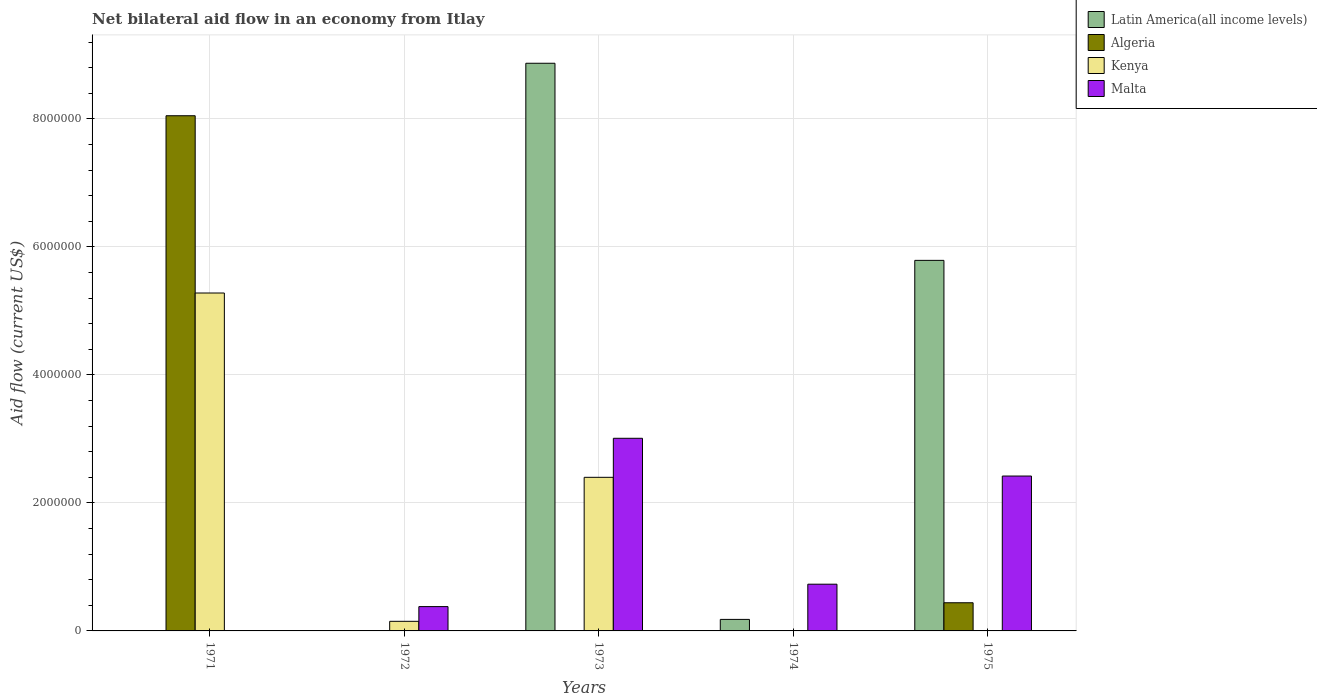Are the number of bars on each tick of the X-axis equal?
Offer a terse response. No. What is the label of the 4th group of bars from the left?
Make the answer very short. 1974. What is the net bilateral aid flow in Kenya in 1973?
Offer a very short reply. 2.40e+06. Across all years, what is the maximum net bilateral aid flow in Kenya?
Give a very brief answer. 5.28e+06. Across all years, what is the minimum net bilateral aid flow in Algeria?
Offer a terse response. 0. What is the total net bilateral aid flow in Malta in the graph?
Your response must be concise. 6.54e+06. What is the difference between the net bilateral aid flow in Kenya in 1971 and that in 1973?
Provide a short and direct response. 2.88e+06. What is the average net bilateral aid flow in Latin America(all income levels) per year?
Provide a short and direct response. 2.97e+06. In the year 1975, what is the difference between the net bilateral aid flow in Algeria and net bilateral aid flow in Malta?
Offer a terse response. -1.98e+06. What is the ratio of the net bilateral aid flow in Malta in 1973 to that in 1975?
Offer a terse response. 1.24. What is the difference between the highest and the second highest net bilateral aid flow in Latin America(all income levels)?
Your answer should be compact. 3.08e+06. What is the difference between the highest and the lowest net bilateral aid flow in Malta?
Your answer should be very brief. 3.01e+06. Is the sum of the net bilateral aid flow in Kenya in 1972 and 1973 greater than the maximum net bilateral aid flow in Malta across all years?
Keep it short and to the point. No. Is it the case that in every year, the sum of the net bilateral aid flow in Kenya and net bilateral aid flow in Malta is greater than the sum of net bilateral aid flow in Latin America(all income levels) and net bilateral aid flow in Algeria?
Offer a terse response. Yes. Are all the bars in the graph horizontal?
Your response must be concise. No. What is the difference between two consecutive major ticks on the Y-axis?
Offer a terse response. 2.00e+06. Does the graph contain grids?
Make the answer very short. Yes. Where does the legend appear in the graph?
Your response must be concise. Top right. How many legend labels are there?
Your response must be concise. 4. What is the title of the graph?
Provide a succinct answer. Net bilateral aid flow in an economy from Itlay. What is the label or title of the X-axis?
Your answer should be very brief. Years. What is the label or title of the Y-axis?
Provide a short and direct response. Aid flow (current US$). What is the Aid flow (current US$) of Latin America(all income levels) in 1971?
Provide a short and direct response. 0. What is the Aid flow (current US$) of Algeria in 1971?
Offer a very short reply. 8.05e+06. What is the Aid flow (current US$) of Kenya in 1971?
Offer a terse response. 5.28e+06. What is the Aid flow (current US$) of Malta in 1971?
Make the answer very short. 0. What is the Aid flow (current US$) of Latin America(all income levels) in 1972?
Provide a succinct answer. 0. What is the Aid flow (current US$) in Latin America(all income levels) in 1973?
Provide a short and direct response. 8.87e+06. What is the Aid flow (current US$) in Algeria in 1973?
Provide a short and direct response. 0. What is the Aid flow (current US$) of Kenya in 1973?
Offer a terse response. 2.40e+06. What is the Aid flow (current US$) of Malta in 1973?
Provide a short and direct response. 3.01e+06. What is the Aid flow (current US$) of Algeria in 1974?
Ensure brevity in your answer.  0. What is the Aid flow (current US$) of Malta in 1974?
Keep it short and to the point. 7.30e+05. What is the Aid flow (current US$) in Latin America(all income levels) in 1975?
Your answer should be very brief. 5.79e+06. What is the Aid flow (current US$) of Kenya in 1975?
Your response must be concise. 0. What is the Aid flow (current US$) in Malta in 1975?
Keep it short and to the point. 2.42e+06. Across all years, what is the maximum Aid flow (current US$) of Latin America(all income levels)?
Provide a short and direct response. 8.87e+06. Across all years, what is the maximum Aid flow (current US$) in Algeria?
Offer a terse response. 8.05e+06. Across all years, what is the maximum Aid flow (current US$) of Kenya?
Offer a terse response. 5.28e+06. Across all years, what is the maximum Aid flow (current US$) of Malta?
Give a very brief answer. 3.01e+06. Across all years, what is the minimum Aid flow (current US$) of Latin America(all income levels)?
Offer a terse response. 0. Across all years, what is the minimum Aid flow (current US$) of Malta?
Your answer should be very brief. 0. What is the total Aid flow (current US$) of Latin America(all income levels) in the graph?
Offer a very short reply. 1.48e+07. What is the total Aid flow (current US$) of Algeria in the graph?
Your answer should be compact. 8.49e+06. What is the total Aid flow (current US$) in Kenya in the graph?
Your answer should be compact. 7.83e+06. What is the total Aid flow (current US$) in Malta in the graph?
Provide a succinct answer. 6.54e+06. What is the difference between the Aid flow (current US$) of Kenya in 1971 and that in 1972?
Your answer should be very brief. 5.13e+06. What is the difference between the Aid flow (current US$) in Kenya in 1971 and that in 1973?
Give a very brief answer. 2.88e+06. What is the difference between the Aid flow (current US$) of Algeria in 1971 and that in 1975?
Offer a terse response. 7.61e+06. What is the difference between the Aid flow (current US$) of Kenya in 1972 and that in 1973?
Your answer should be compact. -2.25e+06. What is the difference between the Aid flow (current US$) of Malta in 1972 and that in 1973?
Your answer should be compact. -2.63e+06. What is the difference between the Aid flow (current US$) in Malta in 1972 and that in 1974?
Your answer should be very brief. -3.50e+05. What is the difference between the Aid flow (current US$) of Malta in 1972 and that in 1975?
Offer a very short reply. -2.04e+06. What is the difference between the Aid flow (current US$) in Latin America(all income levels) in 1973 and that in 1974?
Your response must be concise. 8.69e+06. What is the difference between the Aid flow (current US$) in Malta in 1973 and that in 1974?
Keep it short and to the point. 2.28e+06. What is the difference between the Aid flow (current US$) in Latin America(all income levels) in 1973 and that in 1975?
Provide a succinct answer. 3.08e+06. What is the difference between the Aid flow (current US$) of Malta in 1973 and that in 1975?
Your answer should be very brief. 5.90e+05. What is the difference between the Aid flow (current US$) of Latin America(all income levels) in 1974 and that in 1975?
Your response must be concise. -5.61e+06. What is the difference between the Aid flow (current US$) of Malta in 1974 and that in 1975?
Give a very brief answer. -1.69e+06. What is the difference between the Aid flow (current US$) of Algeria in 1971 and the Aid flow (current US$) of Kenya in 1972?
Offer a terse response. 7.90e+06. What is the difference between the Aid flow (current US$) of Algeria in 1971 and the Aid flow (current US$) of Malta in 1972?
Give a very brief answer. 7.67e+06. What is the difference between the Aid flow (current US$) of Kenya in 1971 and the Aid flow (current US$) of Malta in 1972?
Provide a short and direct response. 4.90e+06. What is the difference between the Aid flow (current US$) of Algeria in 1971 and the Aid flow (current US$) of Kenya in 1973?
Offer a very short reply. 5.65e+06. What is the difference between the Aid flow (current US$) in Algeria in 1971 and the Aid flow (current US$) in Malta in 1973?
Provide a succinct answer. 5.04e+06. What is the difference between the Aid flow (current US$) of Kenya in 1971 and the Aid flow (current US$) of Malta in 1973?
Offer a terse response. 2.27e+06. What is the difference between the Aid flow (current US$) of Algeria in 1971 and the Aid flow (current US$) of Malta in 1974?
Provide a short and direct response. 7.32e+06. What is the difference between the Aid flow (current US$) in Kenya in 1971 and the Aid flow (current US$) in Malta in 1974?
Make the answer very short. 4.55e+06. What is the difference between the Aid flow (current US$) of Algeria in 1971 and the Aid flow (current US$) of Malta in 1975?
Offer a very short reply. 5.63e+06. What is the difference between the Aid flow (current US$) in Kenya in 1971 and the Aid flow (current US$) in Malta in 1975?
Your response must be concise. 2.86e+06. What is the difference between the Aid flow (current US$) in Kenya in 1972 and the Aid flow (current US$) in Malta in 1973?
Provide a short and direct response. -2.86e+06. What is the difference between the Aid flow (current US$) in Kenya in 1972 and the Aid flow (current US$) in Malta in 1974?
Your response must be concise. -5.80e+05. What is the difference between the Aid flow (current US$) of Kenya in 1972 and the Aid flow (current US$) of Malta in 1975?
Provide a short and direct response. -2.27e+06. What is the difference between the Aid flow (current US$) of Latin America(all income levels) in 1973 and the Aid flow (current US$) of Malta in 1974?
Make the answer very short. 8.14e+06. What is the difference between the Aid flow (current US$) in Kenya in 1973 and the Aid flow (current US$) in Malta in 1974?
Make the answer very short. 1.67e+06. What is the difference between the Aid flow (current US$) of Latin America(all income levels) in 1973 and the Aid flow (current US$) of Algeria in 1975?
Provide a succinct answer. 8.43e+06. What is the difference between the Aid flow (current US$) in Latin America(all income levels) in 1973 and the Aid flow (current US$) in Malta in 1975?
Offer a terse response. 6.45e+06. What is the difference between the Aid flow (current US$) in Kenya in 1973 and the Aid flow (current US$) in Malta in 1975?
Your answer should be compact. -2.00e+04. What is the difference between the Aid flow (current US$) of Latin America(all income levels) in 1974 and the Aid flow (current US$) of Malta in 1975?
Offer a terse response. -2.24e+06. What is the average Aid flow (current US$) of Latin America(all income levels) per year?
Your answer should be very brief. 2.97e+06. What is the average Aid flow (current US$) of Algeria per year?
Ensure brevity in your answer.  1.70e+06. What is the average Aid flow (current US$) in Kenya per year?
Your answer should be very brief. 1.57e+06. What is the average Aid flow (current US$) of Malta per year?
Your answer should be very brief. 1.31e+06. In the year 1971, what is the difference between the Aid flow (current US$) of Algeria and Aid flow (current US$) of Kenya?
Give a very brief answer. 2.77e+06. In the year 1973, what is the difference between the Aid flow (current US$) in Latin America(all income levels) and Aid flow (current US$) in Kenya?
Keep it short and to the point. 6.47e+06. In the year 1973, what is the difference between the Aid flow (current US$) of Latin America(all income levels) and Aid flow (current US$) of Malta?
Offer a terse response. 5.86e+06. In the year 1973, what is the difference between the Aid flow (current US$) in Kenya and Aid flow (current US$) in Malta?
Make the answer very short. -6.10e+05. In the year 1974, what is the difference between the Aid flow (current US$) in Latin America(all income levels) and Aid flow (current US$) in Malta?
Offer a very short reply. -5.50e+05. In the year 1975, what is the difference between the Aid flow (current US$) of Latin America(all income levels) and Aid flow (current US$) of Algeria?
Give a very brief answer. 5.35e+06. In the year 1975, what is the difference between the Aid flow (current US$) of Latin America(all income levels) and Aid flow (current US$) of Malta?
Offer a very short reply. 3.37e+06. In the year 1975, what is the difference between the Aid flow (current US$) in Algeria and Aid flow (current US$) in Malta?
Make the answer very short. -1.98e+06. What is the ratio of the Aid flow (current US$) in Kenya in 1971 to that in 1972?
Your answer should be very brief. 35.2. What is the ratio of the Aid flow (current US$) in Kenya in 1971 to that in 1973?
Provide a succinct answer. 2.2. What is the ratio of the Aid flow (current US$) in Algeria in 1971 to that in 1975?
Make the answer very short. 18.3. What is the ratio of the Aid flow (current US$) of Kenya in 1972 to that in 1973?
Offer a terse response. 0.06. What is the ratio of the Aid flow (current US$) in Malta in 1972 to that in 1973?
Your answer should be very brief. 0.13. What is the ratio of the Aid flow (current US$) in Malta in 1972 to that in 1974?
Ensure brevity in your answer.  0.52. What is the ratio of the Aid flow (current US$) of Malta in 1972 to that in 1975?
Offer a very short reply. 0.16. What is the ratio of the Aid flow (current US$) in Latin America(all income levels) in 1973 to that in 1974?
Your answer should be compact. 49.28. What is the ratio of the Aid flow (current US$) in Malta in 1973 to that in 1974?
Your response must be concise. 4.12. What is the ratio of the Aid flow (current US$) in Latin America(all income levels) in 1973 to that in 1975?
Provide a short and direct response. 1.53. What is the ratio of the Aid flow (current US$) in Malta in 1973 to that in 1975?
Your answer should be very brief. 1.24. What is the ratio of the Aid flow (current US$) of Latin America(all income levels) in 1974 to that in 1975?
Keep it short and to the point. 0.03. What is the ratio of the Aid flow (current US$) of Malta in 1974 to that in 1975?
Give a very brief answer. 0.3. What is the difference between the highest and the second highest Aid flow (current US$) of Latin America(all income levels)?
Provide a succinct answer. 3.08e+06. What is the difference between the highest and the second highest Aid flow (current US$) in Kenya?
Offer a very short reply. 2.88e+06. What is the difference between the highest and the second highest Aid flow (current US$) in Malta?
Give a very brief answer. 5.90e+05. What is the difference between the highest and the lowest Aid flow (current US$) of Latin America(all income levels)?
Make the answer very short. 8.87e+06. What is the difference between the highest and the lowest Aid flow (current US$) in Algeria?
Your answer should be compact. 8.05e+06. What is the difference between the highest and the lowest Aid flow (current US$) in Kenya?
Your response must be concise. 5.28e+06. What is the difference between the highest and the lowest Aid flow (current US$) in Malta?
Ensure brevity in your answer.  3.01e+06. 